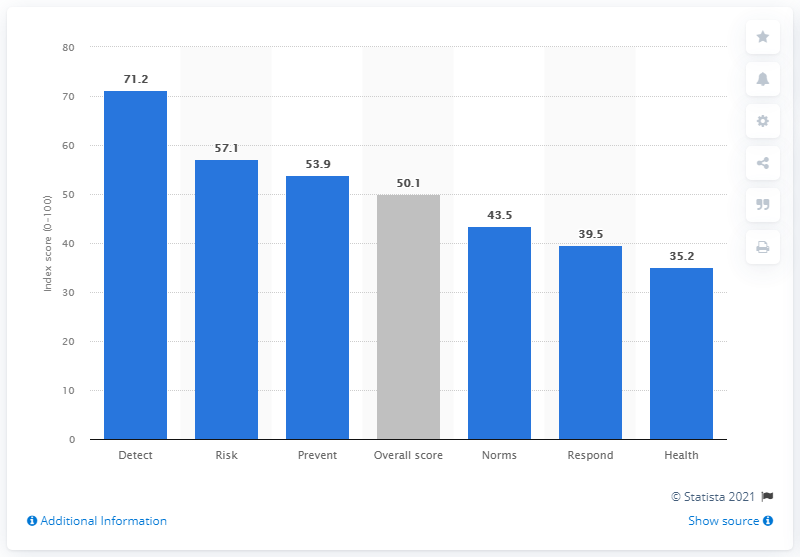Highlight a few significant elements in this photo. In 2019, Ecuador's health security index score was 35.2, indicating a moderate level of health security. In 2019, Ecuador's overall health security index score was 50.1, indicating moderate but improving health security in the country. 